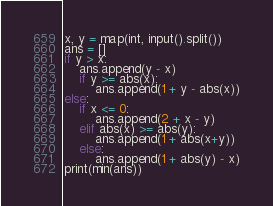<code> <loc_0><loc_0><loc_500><loc_500><_Python_>x, y = map(int, input().split())
ans = []
if y > x:
    ans.append(y - x)
    if y >= abs(x):
        ans.append(1 + y - abs(x))
else:
    if x <= 0:
        ans.append(2 + x - y)
    elif abs(x) >= abs(y):
        ans.append(1 + abs(x+y))
    else:
        ans.append(1 + abs(y) - x)
print(min(ans))</code> 